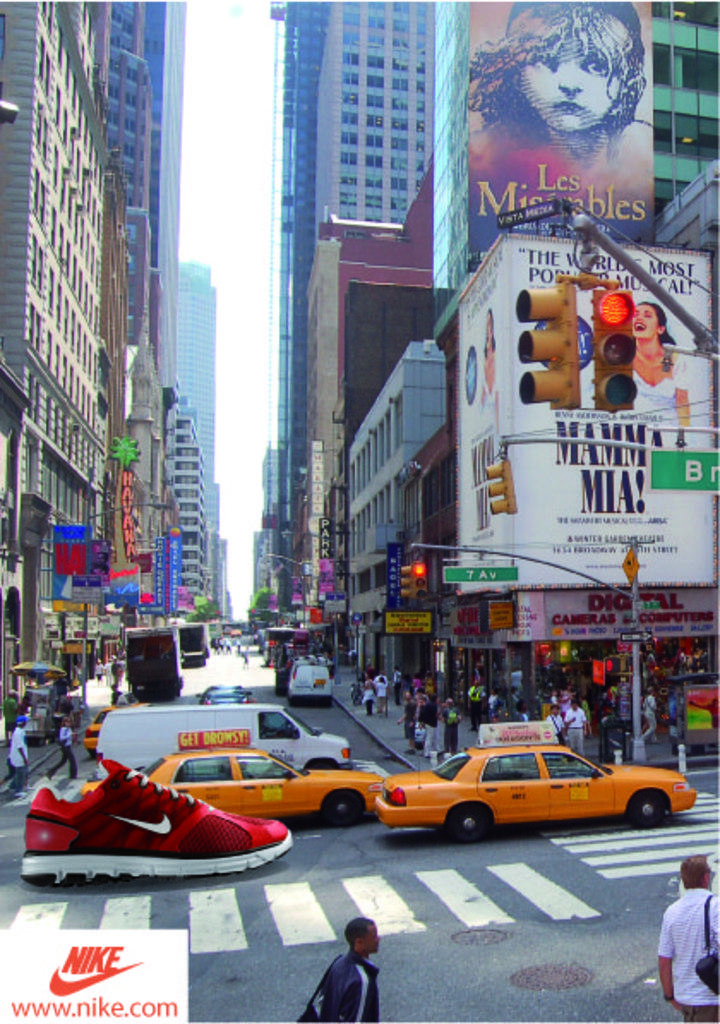What's the logo for inthe bottom left?
Your answer should be compact. Nike. What does it say on the van?
Provide a short and direct response. Get drowsy!. 